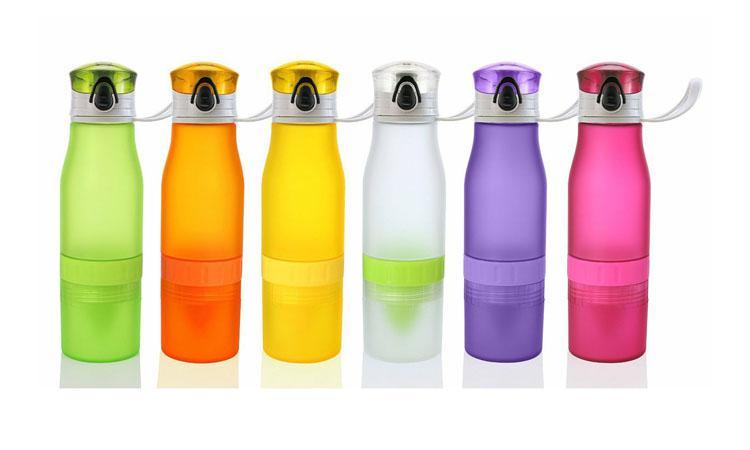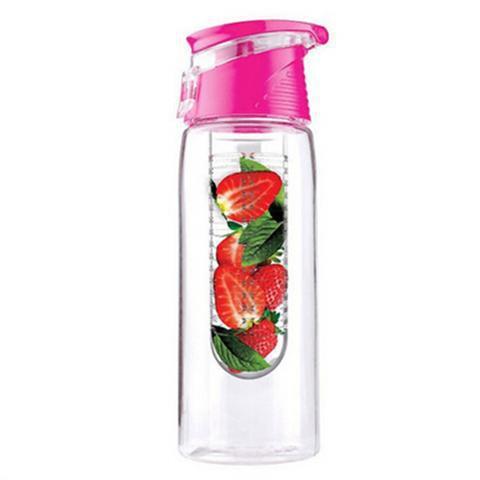The first image is the image on the left, the second image is the image on the right. Given the left and right images, does the statement "There are fruits near the glasses in one of the images." hold true? Answer yes or no. No. 